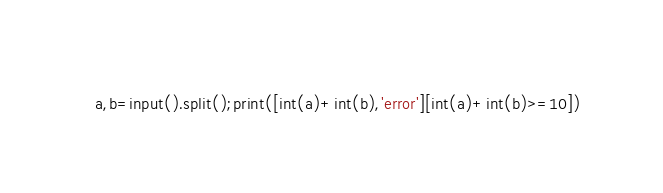<code> <loc_0><loc_0><loc_500><loc_500><_Python_>a,b=input().split();print([int(a)+int(b),'error'][int(a)+int(b)>=10])
</code> 